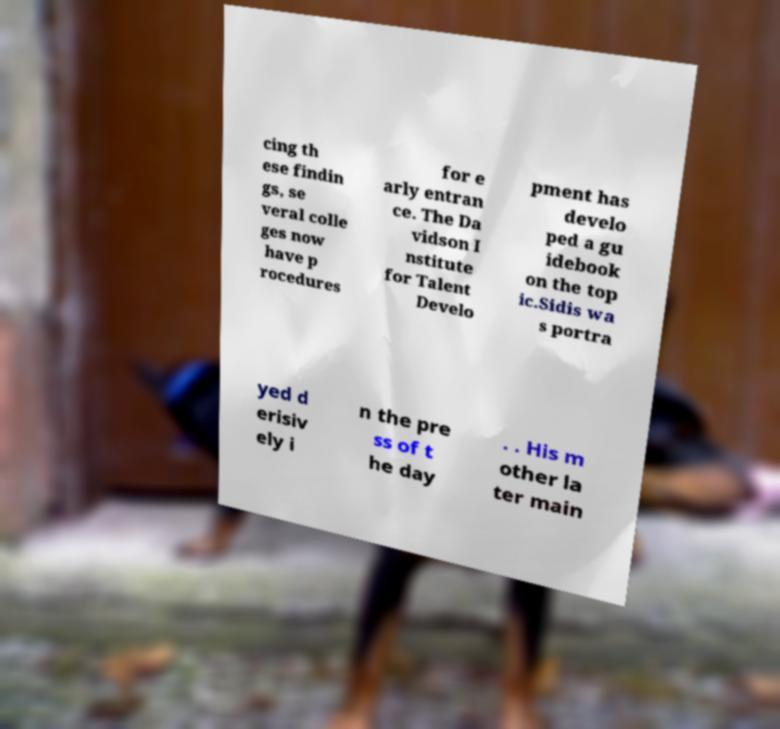For documentation purposes, I need the text within this image transcribed. Could you provide that? cing th ese findin gs, se veral colle ges now have p rocedures for e arly entran ce. The Da vidson I nstitute for Talent Develo pment has develo ped a gu idebook on the top ic.Sidis wa s portra yed d erisiv ely i n the pre ss of t he day . . His m other la ter main 